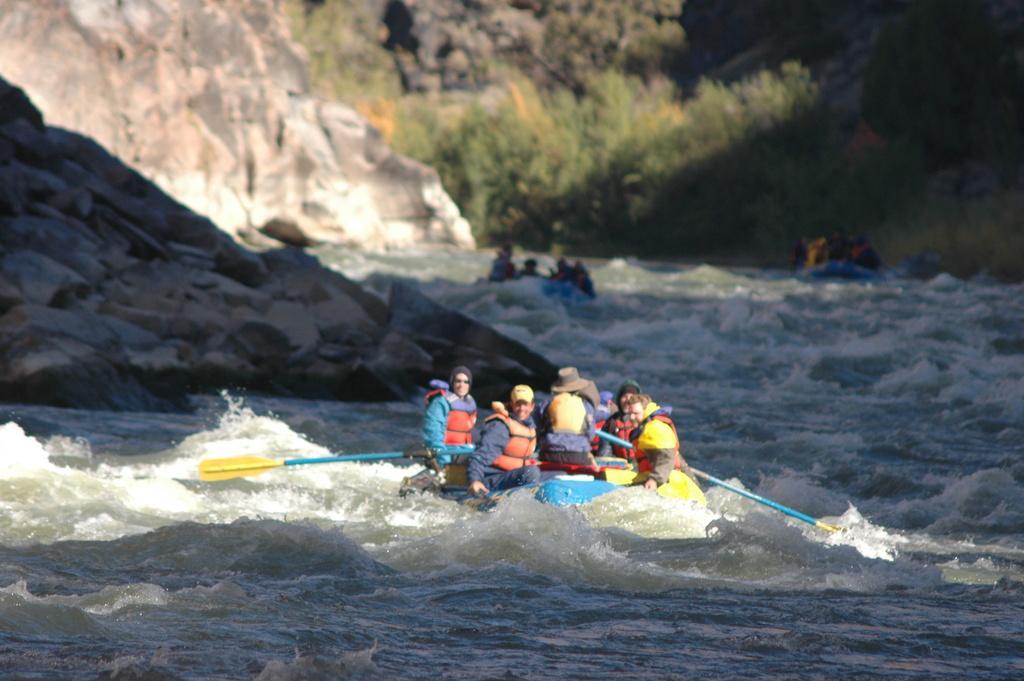How would you summarize this image in a sentence or two? In this image I can see a three boats and group of people sitting on the boat and the boat is on the water. Background I can see trees in green color and I can also see the rock. 